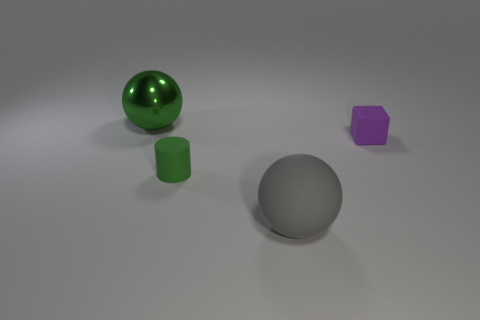Do the sphere that is right of the green rubber cylinder and the green cylinder have the same size?
Your answer should be compact. No. There is a rubber thing that is behind the large gray ball and to the left of the matte block; what size is it?
Offer a very short reply. Small. How many other things are the same shape as the large rubber object?
Provide a succinct answer. 1. How many other things are made of the same material as the green sphere?
Give a very brief answer. 0. There is another thing that is the same shape as the large matte object; what size is it?
Provide a short and direct response. Large. Do the tiny matte cylinder and the large metal sphere have the same color?
Your answer should be very brief. Yes. The object that is behind the green cylinder and in front of the metal thing is what color?
Your answer should be very brief. Purple. What number of things are big things that are in front of the tiny block or small purple rubber blocks?
Keep it short and to the point. 2. There is a matte thing that is the same shape as the green shiny thing; what color is it?
Give a very brief answer. Gray. There is a big metallic thing; does it have the same shape as the big thing that is in front of the small purple rubber thing?
Offer a very short reply. Yes. 